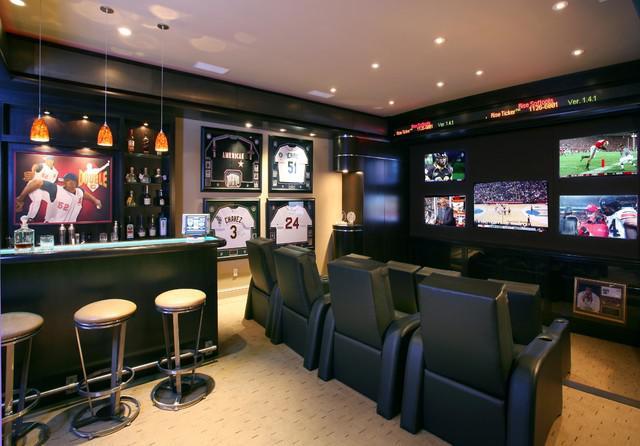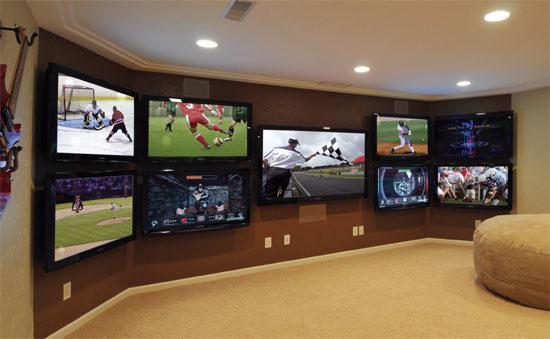The first image is the image on the left, the second image is the image on the right. Analyze the images presented: Is the assertion "there are lights haging over the bar" valid? Answer yes or no. Yes. 